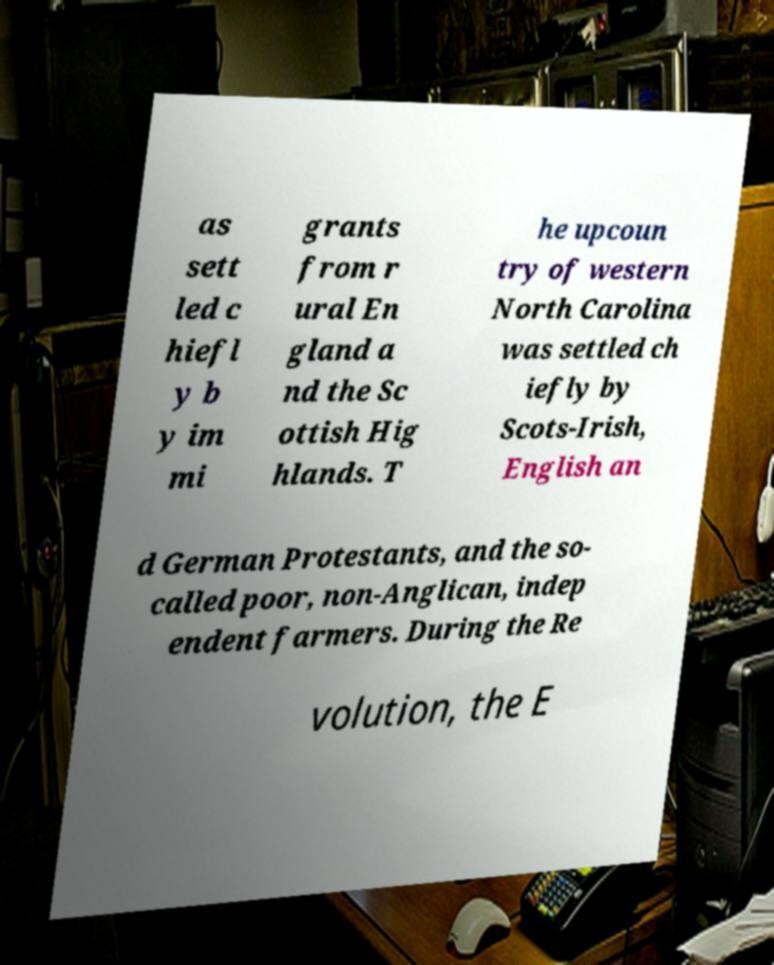Could you extract and type out the text from this image? as sett led c hiefl y b y im mi grants from r ural En gland a nd the Sc ottish Hig hlands. T he upcoun try of western North Carolina was settled ch iefly by Scots-Irish, English an d German Protestants, and the so- called poor, non-Anglican, indep endent farmers. During the Re volution, the E 